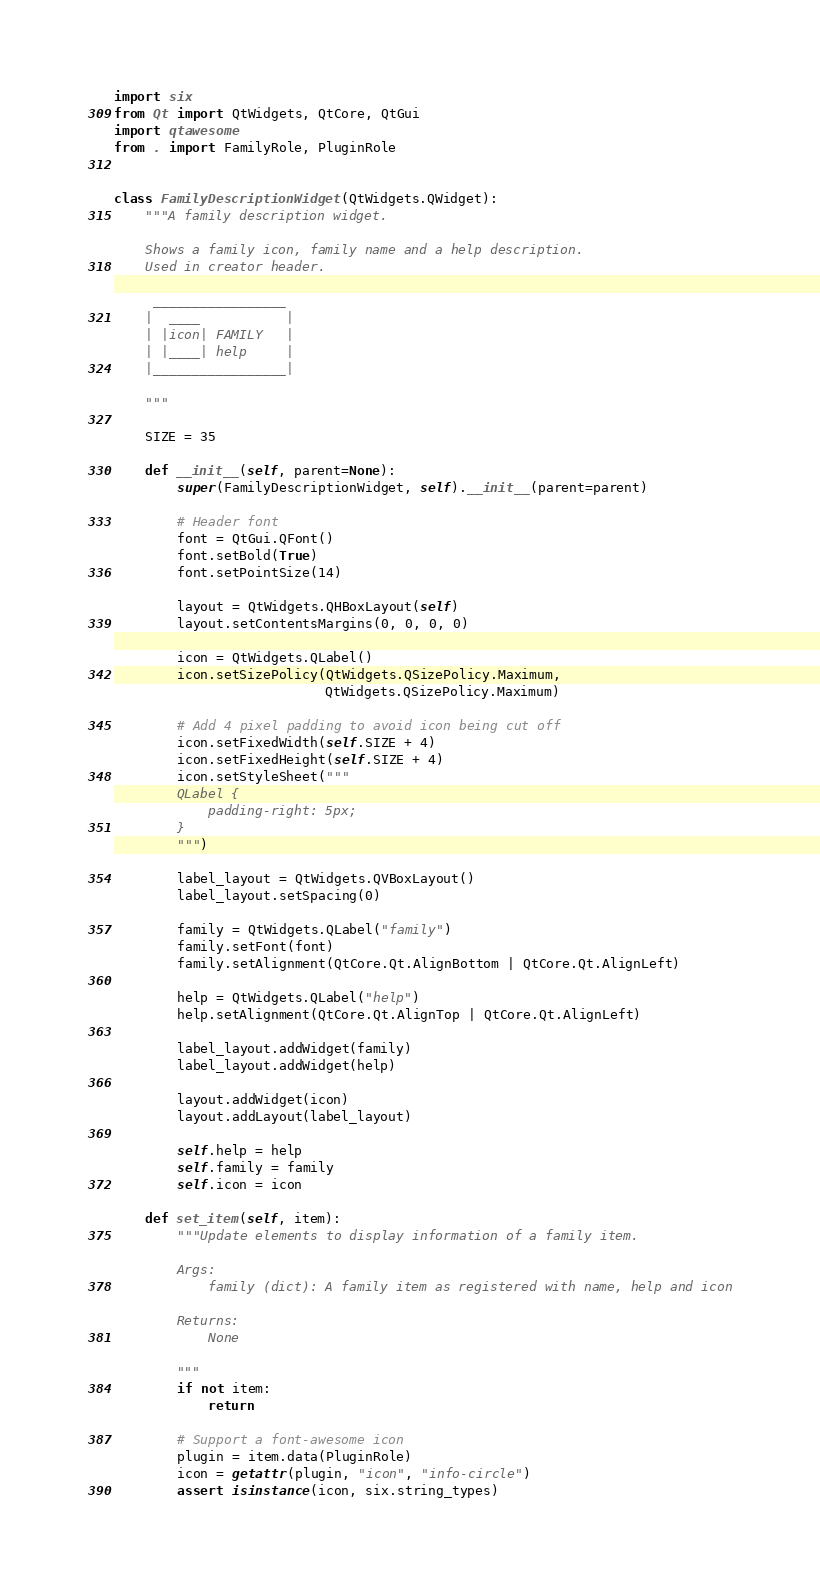Convert code to text. <code><loc_0><loc_0><loc_500><loc_500><_Python_>import six
from Qt import QtWidgets, QtCore, QtGui
import qtawesome
from . import FamilyRole, PluginRole


class FamilyDescriptionWidget(QtWidgets.QWidget):
    """A family description widget.

    Shows a family icon, family name and a help description.
    Used in creator header.

     _________________
    |  ____           |
    | |icon| FAMILY   |
    | |____| help     |
    |_________________|

    """

    SIZE = 35

    def __init__(self, parent=None):
        super(FamilyDescriptionWidget, self).__init__(parent=parent)

        # Header font
        font = QtGui.QFont()
        font.setBold(True)
        font.setPointSize(14)

        layout = QtWidgets.QHBoxLayout(self)
        layout.setContentsMargins(0, 0, 0, 0)

        icon = QtWidgets.QLabel()
        icon.setSizePolicy(QtWidgets.QSizePolicy.Maximum,
                           QtWidgets.QSizePolicy.Maximum)

        # Add 4 pixel padding to avoid icon being cut off
        icon.setFixedWidth(self.SIZE + 4)
        icon.setFixedHeight(self.SIZE + 4)
        icon.setStyleSheet("""
        QLabel {
            padding-right: 5px;
        }
        """)

        label_layout = QtWidgets.QVBoxLayout()
        label_layout.setSpacing(0)

        family = QtWidgets.QLabel("family")
        family.setFont(font)
        family.setAlignment(QtCore.Qt.AlignBottom | QtCore.Qt.AlignLeft)

        help = QtWidgets.QLabel("help")
        help.setAlignment(QtCore.Qt.AlignTop | QtCore.Qt.AlignLeft)

        label_layout.addWidget(family)
        label_layout.addWidget(help)

        layout.addWidget(icon)
        layout.addLayout(label_layout)

        self.help = help
        self.family = family
        self.icon = icon

    def set_item(self, item):
        """Update elements to display information of a family item.

        Args:
            family (dict): A family item as registered with name, help and icon

        Returns:
            None

        """
        if not item:
            return

        # Support a font-awesome icon
        plugin = item.data(PluginRole)
        icon = getattr(plugin, "icon", "info-circle")
        assert isinstance(icon, six.string_types)</code> 